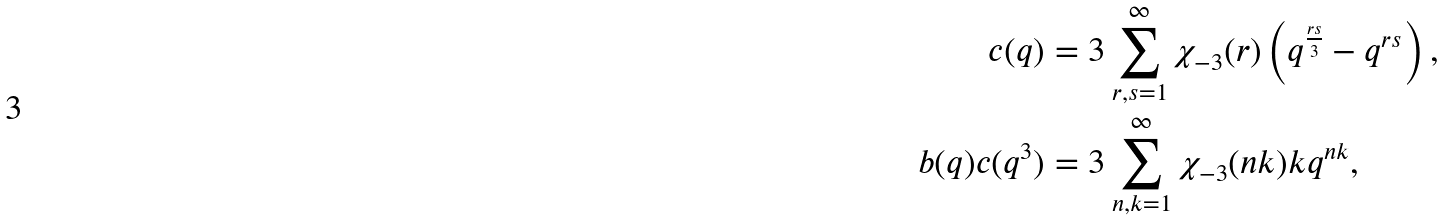Convert formula to latex. <formula><loc_0><loc_0><loc_500><loc_500>c ( q ) & = 3 \sum _ { r , s = 1 } ^ { \infty } \chi _ { - 3 } ( r ) \left ( q ^ { \frac { r s } { 3 } } - q ^ { r s } \right ) , \\ b ( q ) c ( q ^ { 3 } ) & = 3 \sum _ { n , k = 1 } ^ { \infty } \chi _ { - 3 } ( n k ) k q ^ { n k } ,</formula> 